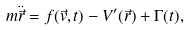<formula> <loc_0><loc_0><loc_500><loc_500>m \ddot { \vec { r } } = f ( \vec { v } , t ) - V ^ { \prime } ( \vec { r } ) + \Gamma ( t ) ,</formula> 